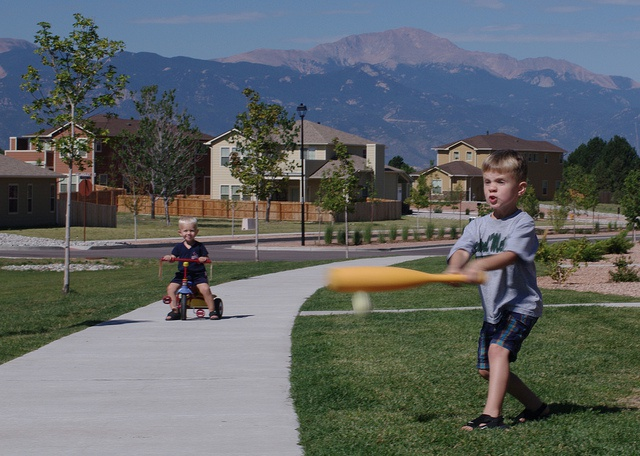Describe the objects in this image and their specific colors. I can see people in gray, black, and darkgray tones, people in gray, black, and darkgray tones, baseball bat in gray, tan, olive, and maroon tones, bicycle in gray, black, maroon, and olive tones, and sports ball in gray and darkgray tones in this image. 